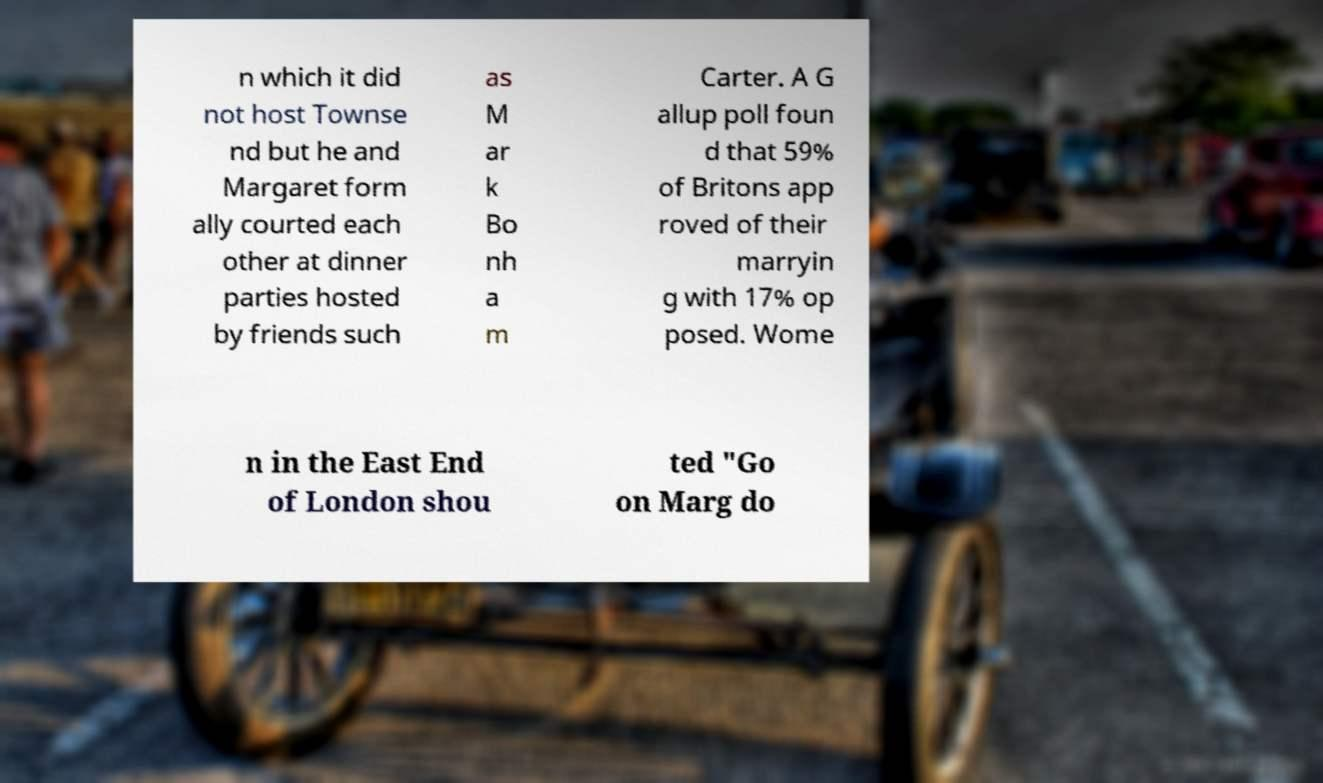Please read and relay the text visible in this image. What does it say? n which it did not host Townse nd but he and Margaret form ally courted each other at dinner parties hosted by friends such as M ar k Bo nh a m Carter. A G allup poll foun d that 59% of Britons app roved of their marryin g with 17% op posed. Wome n in the East End of London shou ted "Go on Marg do 